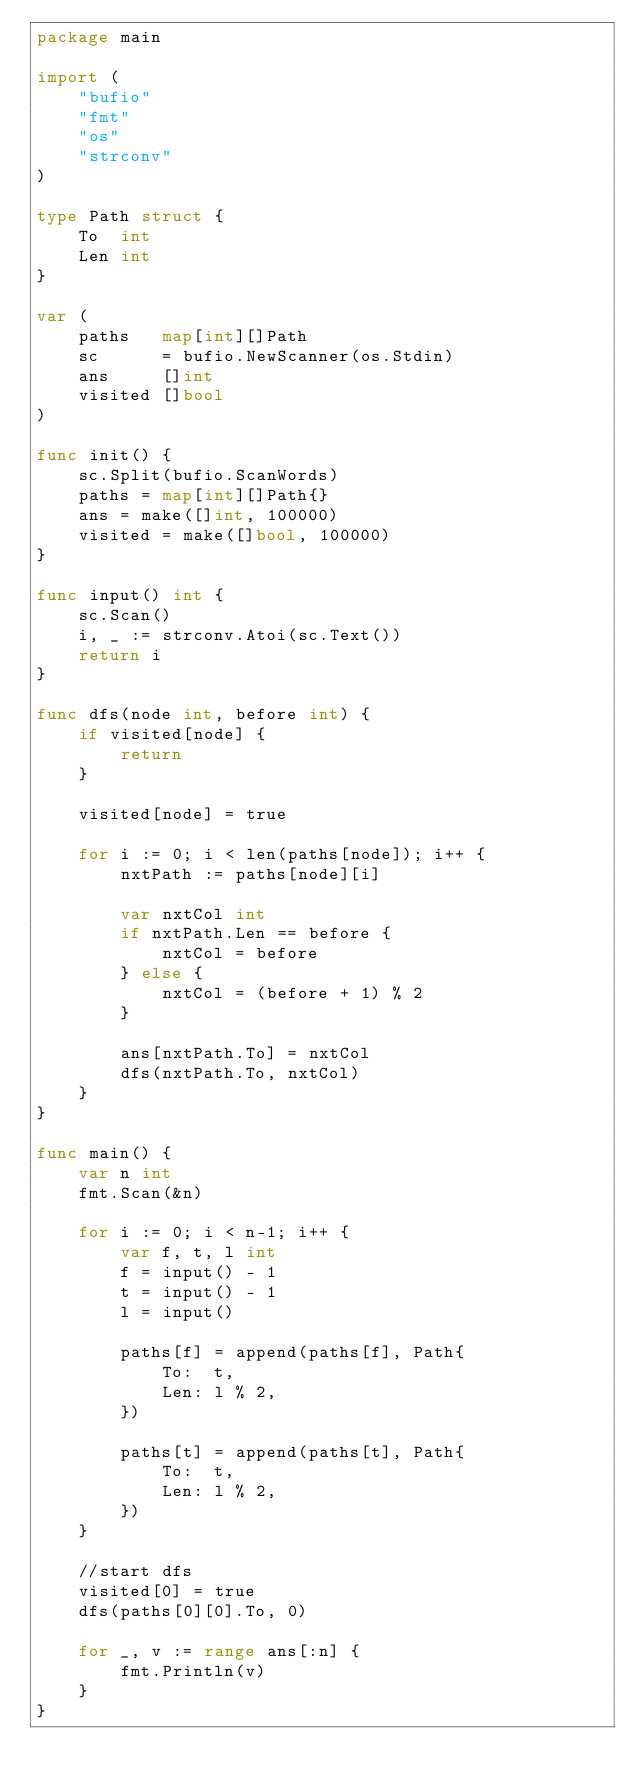<code> <loc_0><loc_0><loc_500><loc_500><_Go_>package main

import (
	"bufio"
	"fmt"
	"os"
	"strconv"
)

type Path struct {
	To  int
	Len int
}

var (
	paths   map[int][]Path
	sc      = bufio.NewScanner(os.Stdin)
	ans     []int
	visited []bool
)

func init() {
	sc.Split(bufio.ScanWords)
	paths = map[int][]Path{}
	ans = make([]int, 100000)
	visited = make([]bool, 100000)
}

func input() int {
	sc.Scan()
	i, _ := strconv.Atoi(sc.Text())
	return i
}

func dfs(node int, before int) {
	if visited[node] {
		return
	}

	visited[node] = true

	for i := 0; i < len(paths[node]); i++ {
		nxtPath := paths[node][i]

		var nxtCol int
		if nxtPath.Len == before {
			nxtCol = before
		} else {
			nxtCol = (before + 1) % 2
		}

		ans[nxtPath.To] = nxtCol
		dfs(nxtPath.To, nxtCol)
	}
}

func main() {
	var n int
	fmt.Scan(&n)

	for i := 0; i < n-1; i++ {
		var f, t, l int
		f = input() - 1
		t = input() - 1
		l = input()

		paths[f] = append(paths[f], Path{
			To:  t,
			Len: l % 2,
		})

		paths[t] = append(paths[t], Path{
			To:  t,
			Len: l % 2,
		})
	}

	//start dfs
	visited[0] = true
	dfs(paths[0][0].To, 0)

	for _, v := range ans[:n] {
		fmt.Println(v)
	}
}</code> 